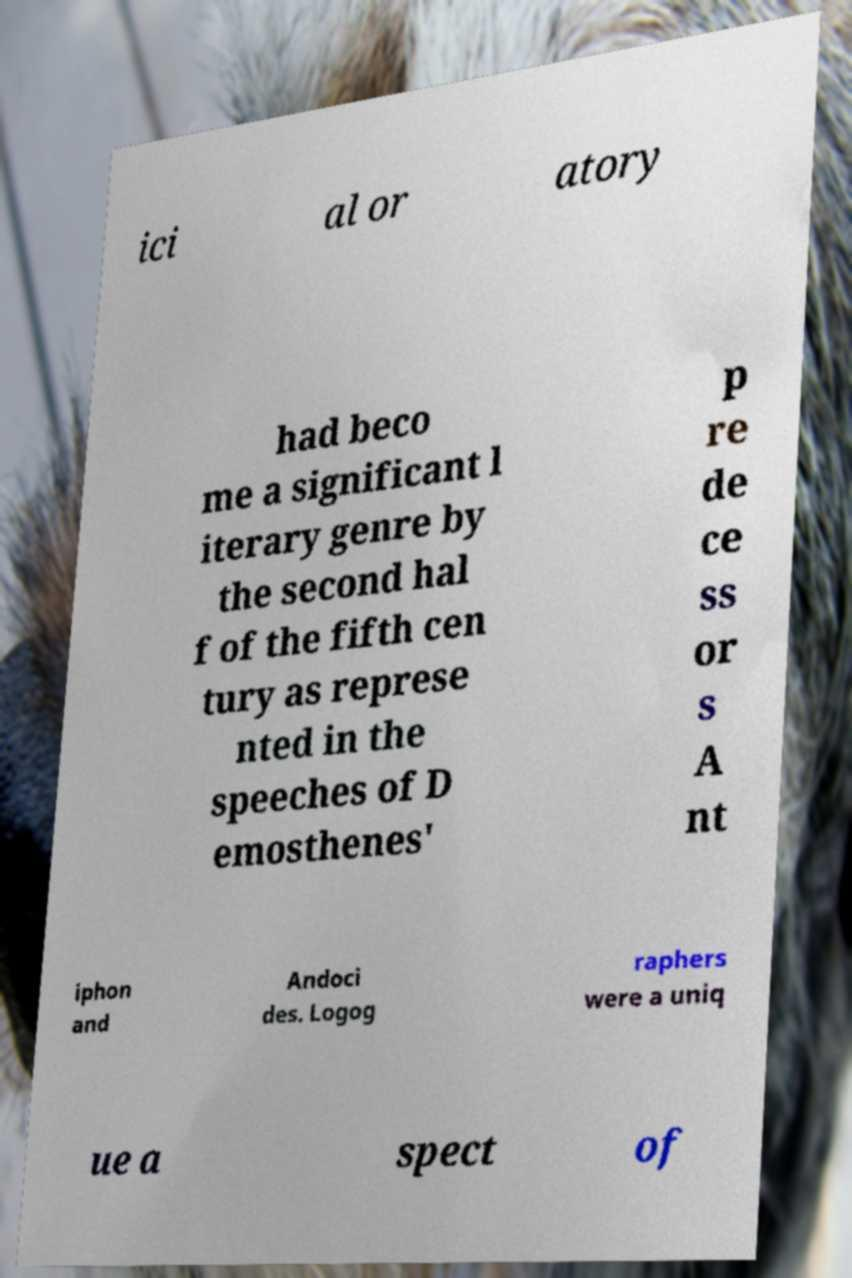Please read and relay the text visible in this image. What does it say? ici al or atory had beco me a significant l iterary genre by the second hal f of the fifth cen tury as represe nted in the speeches of D emosthenes' p re de ce ss or s A nt iphon and Andoci des. Logog raphers were a uniq ue a spect of 